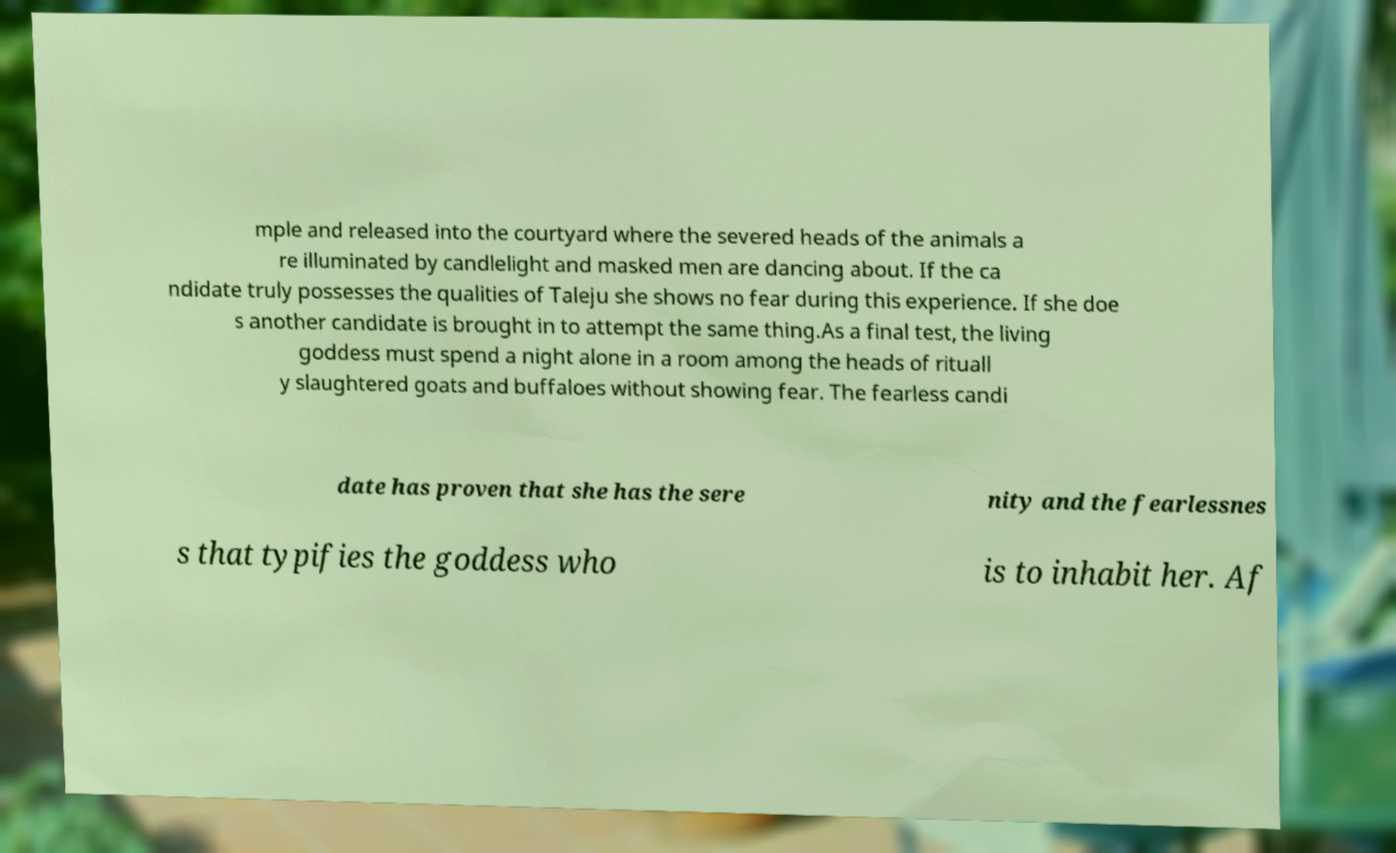For documentation purposes, I need the text within this image transcribed. Could you provide that? mple and released into the courtyard where the severed heads of the animals a re illuminated by candlelight and masked men are dancing about. If the ca ndidate truly possesses the qualities of Taleju she shows no fear during this experience. If she doe s another candidate is brought in to attempt the same thing.As a final test, the living goddess must spend a night alone in a room among the heads of rituall y slaughtered goats and buffaloes without showing fear. The fearless candi date has proven that she has the sere nity and the fearlessnes s that typifies the goddess who is to inhabit her. Af 